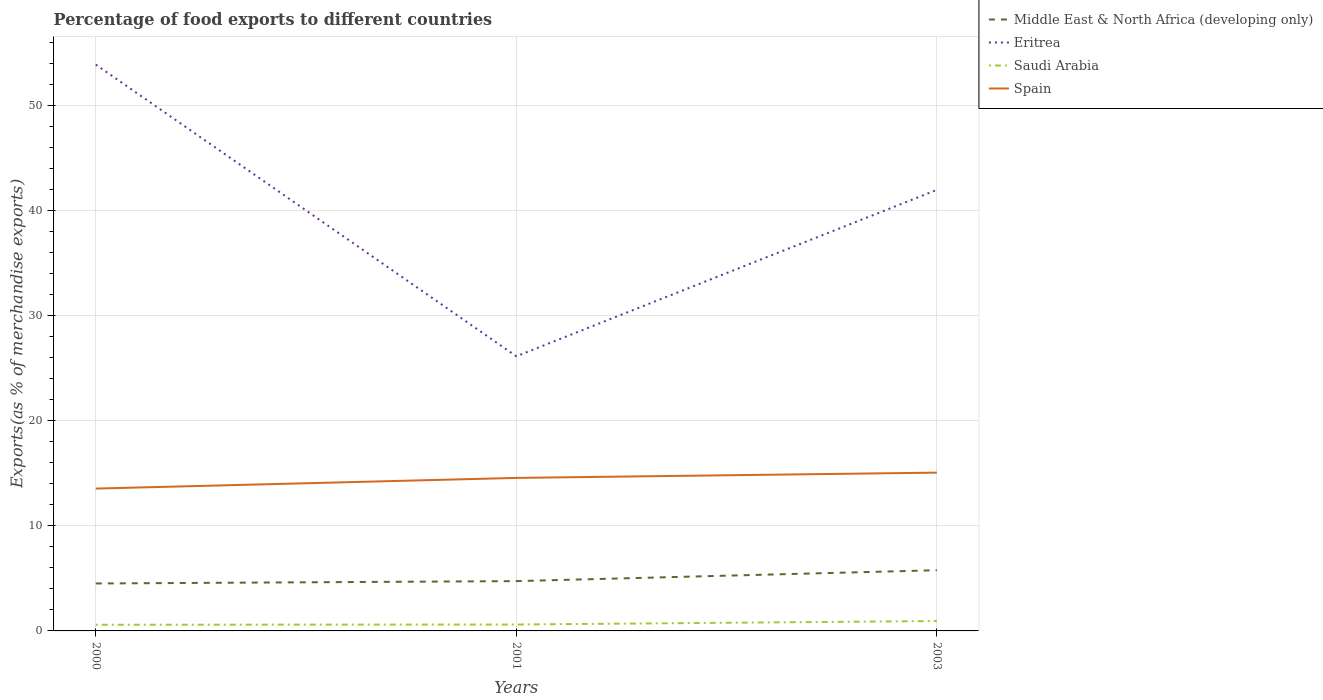How many different coloured lines are there?
Offer a very short reply. 4. Does the line corresponding to Spain intersect with the line corresponding to Middle East & North Africa (developing only)?
Offer a very short reply. No. Is the number of lines equal to the number of legend labels?
Your answer should be very brief. Yes. Across all years, what is the maximum percentage of exports to different countries in Eritrea?
Your response must be concise. 26.15. In which year was the percentage of exports to different countries in Middle East & North Africa (developing only) maximum?
Provide a succinct answer. 2000. What is the total percentage of exports to different countries in Spain in the graph?
Provide a short and direct response. -1.52. What is the difference between the highest and the second highest percentage of exports to different countries in Middle East & North Africa (developing only)?
Offer a very short reply. 1.26. What is the difference between the highest and the lowest percentage of exports to different countries in Saudi Arabia?
Your response must be concise. 1. Is the percentage of exports to different countries in Saudi Arabia strictly greater than the percentage of exports to different countries in Eritrea over the years?
Offer a very short reply. Yes. How many years are there in the graph?
Provide a succinct answer. 3. Does the graph contain grids?
Keep it short and to the point. Yes. How are the legend labels stacked?
Offer a very short reply. Vertical. What is the title of the graph?
Give a very brief answer. Percentage of food exports to different countries. Does "Lower middle income" appear as one of the legend labels in the graph?
Provide a succinct answer. No. What is the label or title of the X-axis?
Make the answer very short. Years. What is the label or title of the Y-axis?
Your answer should be very brief. Exports(as % of merchandise exports). What is the Exports(as % of merchandise exports) in Middle East & North Africa (developing only) in 2000?
Your answer should be compact. 4.52. What is the Exports(as % of merchandise exports) in Eritrea in 2000?
Offer a very short reply. 53.91. What is the Exports(as % of merchandise exports) in Saudi Arabia in 2000?
Your response must be concise. 0.59. What is the Exports(as % of merchandise exports) in Spain in 2000?
Provide a succinct answer. 13.55. What is the Exports(as % of merchandise exports) in Middle East & North Africa (developing only) in 2001?
Keep it short and to the point. 4.74. What is the Exports(as % of merchandise exports) in Eritrea in 2001?
Provide a short and direct response. 26.15. What is the Exports(as % of merchandise exports) in Saudi Arabia in 2001?
Offer a very short reply. 0.61. What is the Exports(as % of merchandise exports) of Spain in 2001?
Ensure brevity in your answer.  14.57. What is the Exports(as % of merchandise exports) in Middle East & North Africa (developing only) in 2003?
Your response must be concise. 5.78. What is the Exports(as % of merchandise exports) in Eritrea in 2003?
Keep it short and to the point. 41.99. What is the Exports(as % of merchandise exports) of Saudi Arabia in 2003?
Offer a very short reply. 0.94. What is the Exports(as % of merchandise exports) in Spain in 2003?
Give a very brief answer. 15.07. Across all years, what is the maximum Exports(as % of merchandise exports) of Middle East & North Africa (developing only)?
Your response must be concise. 5.78. Across all years, what is the maximum Exports(as % of merchandise exports) of Eritrea?
Offer a terse response. 53.91. Across all years, what is the maximum Exports(as % of merchandise exports) of Saudi Arabia?
Your answer should be compact. 0.94. Across all years, what is the maximum Exports(as % of merchandise exports) in Spain?
Your answer should be compact. 15.07. Across all years, what is the minimum Exports(as % of merchandise exports) of Middle East & North Africa (developing only)?
Give a very brief answer. 4.52. Across all years, what is the minimum Exports(as % of merchandise exports) of Eritrea?
Your response must be concise. 26.15. Across all years, what is the minimum Exports(as % of merchandise exports) in Saudi Arabia?
Make the answer very short. 0.59. Across all years, what is the minimum Exports(as % of merchandise exports) of Spain?
Give a very brief answer. 13.55. What is the total Exports(as % of merchandise exports) of Middle East & North Africa (developing only) in the graph?
Make the answer very short. 15.04. What is the total Exports(as % of merchandise exports) of Eritrea in the graph?
Provide a short and direct response. 122.05. What is the total Exports(as % of merchandise exports) in Saudi Arabia in the graph?
Your response must be concise. 2.14. What is the total Exports(as % of merchandise exports) of Spain in the graph?
Make the answer very short. 43.19. What is the difference between the Exports(as % of merchandise exports) of Middle East & North Africa (developing only) in 2000 and that in 2001?
Your answer should be compact. -0.22. What is the difference between the Exports(as % of merchandise exports) in Eritrea in 2000 and that in 2001?
Make the answer very short. 27.77. What is the difference between the Exports(as % of merchandise exports) of Saudi Arabia in 2000 and that in 2001?
Ensure brevity in your answer.  -0.02. What is the difference between the Exports(as % of merchandise exports) in Spain in 2000 and that in 2001?
Your response must be concise. -1.02. What is the difference between the Exports(as % of merchandise exports) in Middle East & North Africa (developing only) in 2000 and that in 2003?
Offer a terse response. -1.26. What is the difference between the Exports(as % of merchandise exports) of Eritrea in 2000 and that in 2003?
Ensure brevity in your answer.  11.93. What is the difference between the Exports(as % of merchandise exports) in Saudi Arabia in 2000 and that in 2003?
Your answer should be compact. -0.36. What is the difference between the Exports(as % of merchandise exports) in Spain in 2000 and that in 2003?
Provide a short and direct response. -1.52. What is the difference between the Exports(as % of merchandise exports) of Middle East & North Africa (developing only) in 2001 and that in 2003?
Your response must be concise. -1.04. What is the difference between the Exports(as % of merchandise exports) in Eritrea in 2001 and that in 2003?
Offer a very short reply. -15.84. What is the difference between the Exports(as % of merchandise exports) in Saudi Arabia in 2001 and that in 2003?
Your answer should be very brief. -0.33. What is the difference between the Exports(as % of merchandise exports) of Spain in 2001 and that in 2003?
Ensure brevity in your answer.  -0.5. What is the difference between the Exports(as % of merchandise exports) in Middle East & North Africa (developing only) in 2000 and the Exports(as % of merchandise exports) in Eritrea in 2001?
Make the answer very short. -21.63. What is the difference between the Exports(as % of merchandise exports) in Middle East & North Africa (developing only) in 2000 and the Exports(as % of merchandise exports) in Saudi Arabia in 2001?
Give a very brief answer. 3.91. What is the difference between the Exports(as % of merchandise exports) in Middle East & North Africa (developing only) in 2000 and the Exports(as % of merchandise exports) in Spain in 2001?
Provide a succinct answer. -10.05. What is the difference between the Exports(as % of merchandise exports) of Eritrea in 2000 and the Exports(as % of merchandise exports) of Saudi Arabia in 2001?
Keep it short and to the point. 53.31. What is the difference between the Exports(as % of merchandise exports) of Eritrea in 2000 and the Exports(as % of merchandise exports) of Spain in 2001?
Your response must be concise. 39.35. What is the difference between the Exports(as % of merchandise exports) of Saudi Arabia in 2000 and the Exports(as % of merchandise exports) of Spain in 2001?
Your response must be concise. -13.98. What is the difference between the Exports(as % of merchandise exports) in Middle East & North Africa (developing only) in 2000 and the Exports(as % of merchandise exports) in Eritrea in 2003?
Provide a short and direct response. -37.47. What is the difference between the Exports(as % of merchandise exports) in Middle East & North Africa (developing only) in 2000 and the Exports(as % of merchandise exports) in Saudi Arabia in 2003?
Provide a succinct answer. 3.57. What is the difference between the Exports(as % of merchandise exports) of Middle East & North Africa (developing only) in 2000 and the Exports(as % of merchandise exports) of Spain in 2003?
Your answer should be very brief. -10.55. What is the difference between the Exports(as % of merchandise exports) of Eritrea in 2000 and the Exports(as % of merchandise exports) of Saudi Arabia in 2003?
Provide a short and direct response. 52.97. What is the difference between the Exports(as % of merchandise exports) of Eritrea in 2000 and the Exports(as % of merchandise exports) of Spain in 2003?
Your response must be concise. 38.85. What is the difference between the Exports(as % of merchandise exports) in Saudi Arabia in 2000 and the Exports(as % of merchandise exports) in Spain in 2003?
Your answer should be compact. -14.48. What is the difference between the Exports(as % of merchandise exports) of Middle East & North Africa (developing only) in 2001 and the Exports(as % of merchandise exports) of Eritrea in 2003?
Offer a terse response. -37.25. What is the difference between the Exports(as % of merchandise exports) in Middle East & North Africa (developing only) in 2001 and the Exports(as % of merchandise exports) in Saudi Arabia in 2003?
Make the answer very short. 3.8. What is the difference between the Exports(as % of merchandise exports) of Middle East & North Africa (developing only) in 2001 and the Exports(as % of merchandise exports) of Spain in 2003?
Provide a short and direct response. -10.33. What is the difference between the Exports(as % of merchandise exports) of Eritrea in 2001 and the Exports(as % of merchandise exports) of Saudi Arabia in 2003?
Make the answer very short. 25.2. What is the difference between the Exports(as % of merchandise exports) of Eritrea in 2001 and the Exports(as % of merchandise exports) of Spain in 2003?
Provide a short and direct response. 11.08. What is the difference between the Exports(as % of merchandise exports) of Saudi Arabia in 2001 and the Exports(as % of merchandise exports) of Spain in 2003?
Your answer should be compact. -14.46. What is the average Exports(as % of merchandise exports) of Middle East & North Africa (developing only) per year?
Your answer should be very brief. 5.01. What is the average Exports(as % of merchandise exports) in Eritrea per year?
Make the answer very short. 40.68. What is the average Exports(as % of merchandise exports) in Saudi Arabia per year?
Offer a very short reply. 0.71. What is the average Exports(as % of merchandise exports) in Spain per year?
Your answer should be compact. 14.39. In the year 2000, what is the difference between the Exports(as % of merchandise exports) of Middle East & North Africa (developing only) and Exports(as % of merchandise exports) of Eritrea?
Ensure brevity in your answer.  -49.4. In the year 2000, what is the difference between the Exports(as % of merchandise exports) in Middle East & North Africa (developing only) and Exports(as % of merchandise exports) in Saudi Arabia?
Give a very brief answer. 3.93. In the year 2000, what is the difference between the Exports(as % of merchandise exports) in Middle East & North Africa (developing only) and Exports(as % of merchandise exports) in Spain?
Your answer should be compact. -9.03. In the year 2000, what is the difference between the Exports(as % of merchandise exports) in Eritrea and Exports(as % of merchandise exports) in Saudi Arabia?
Provide a succinct answer. 53.33. In the year 2000, what is the difference between the Exports(as % of merchandise exports) in Eritrea and Exports(as % of merchandise exports) in Spain?
Your response must be concise. 40.37. In the year 2000, what is the difference between the Exports(as % of merchandise exports) in Saudi Arabia and Exports(as % of merchandise exports) in Spain?
Your answer should be compact. -12.96. In the year 2001, what is the difference between the Exports(as % of merchandise exports) in Middle East & North Africa (developing only) and Exports(as % of merchandise exports) in Eritrea?
Provide a succinct answer. -21.4. In the year 2001, what is the difference between the Exports(as % of merchandise exports) in Middle East & North Africa (developing only) and Exports(as % of merchandise exports) in Saudi Arabia?
Make the answer very short. 4.13. In the year 2001, what is the difference between the Exports(as % of merchandise exports) in Middle East & North Africa (developing only) and Exports(as % of merchandise exports) in Spain?
Offer a terse response. -9.83. In the year 2001, what is the difference between the Exports(as % of merchandise exports) of Eritrea and Exports(as % of merchandise exports) of Saudi Arabia?
Ensure brevity in your answer.  25.54. In the year 2001, what is the difference between the Exports(as % of merchandise exports) in Eritrea and Exports(as % of merchandise exports) in Spain?
Your answer should be very brief. 11.58. In the year 2001, what is the difference between the Exports(as % of merchandise exports) in Saudi Arabia and Exports(as % of merchandise exports) in Spain?
Make the answer very short. -13.96. In the year 2003, what is the difference between the Exports(as % of merchandise exports) of Middle East & North Africa (developing only) and Exports(as % of merchandise exports) of Eritrea?
Provide a short and direct response. -36.21. In the year 2003, what is the difference between the Exports(as % of merchandise exports) of Middle East & North Africa (developing only) and Exports(as % of merchandise exports) of Saudi Arabia?
Your answer should be compact. 4.84. In the year 2003, what is the difference between the Exports(as % of merchandise exports) in Middle East & North Africa (developing only) and Exports(as % of merchandise exports) in Spain?
Your answer should be very brief. -9.29. In the year 2003, what is the difference between the Exports(as % of merchandise exports) of Eritrea and Exports(as % of merchandise exports) of Saudi Arabia?
Ensure brevity in your answer.  41.04. In the year 2003, what is the difference between the Exports(as % of merchandise exports) of Eritrea and Exports(as % of merchandise exports) of Spain?
Make the answer very short. 26.92. In the year 2003, what is the difference between the Exports(as % of merchandise exports) of Saudi Arabia and Exports(as % of merchandise exports) of Spain?
Your answer should be very brief. -14.13. What is the ratio of the Exports(as % of merchandise exports) in Middle East & North Africa (developing only) in 2000 to that in 2001?
Offer a terse response. 0.95. What is the ratio of the Exports(as % of merchandise exports) of Eritrea in 2000 to that in 2001?
Offer a very short reply. 2.06. What is the ratio of the Exports(as % of merchandise exports) of Saudi Arabia in 2000 to that in 2001?
Provide a short and direct response. 0.96. What is the ratio of the Exports(as % of merchandise exports) in Spain in 2000 to that in 2001?
Keep it short and to the point. 0.93. What is the ratio of the Exports(as % of merchandise exports) in Middle East & North Africa (developing only) in 2000 to that in 2003?
Offer a very short reply. 0.78. What is the ratio of the Exports(as % of merchandise exports) in Eritrea in 2000 to that in 2003?
Give a very brief answer. 1.28. What is the ratio of the Exports(as % of merchandise exports) in Saudi Arabia in 2000 to that in 2003?
Make the answer very short. 0.62. What is the ratio of the Exports(as % of merchandise exports) of Spain in 2000 to that in 2003?
Keep it short and to the point. 0.9. What is the ratio of the Exports(as % of merchandise exports) of Middle East & North Africa (developing only) in 2001 to that in 2003?
Your answer should be very brief. 0.82. What is the ratio of the Exports(as % of merchandise exports) in Eritrea in 2001 to that in 2003?
Ensure brevity in your answer.  0.62. What is the ratio of the Exports(as % of merchandise exports) in Saudi Arabia in 2001 to that in 2003?
Your answer should be very brief. 0.65. What is the ratio of the Exports(as % of merchandise exports) in Spain in 2001 to that in 2003?
Your answer should be compact. 0.97. What is the difference between the highest and the second highest Exports(as % of merchandise exports) in Middle East & North Africa (developing only)?
Offer a terse response. 1.04. What is the difference between the highest and the second highest Exports(as % of merchandise exports) in Eritrea?
Keep it short and to the point. 11.93. What is the difference between the highest and the second highest Exports(as % of merchandise exports) in Saudi Arabia?
Your answer should be compact. 0.33. What is the difference between the highest and the second highest Exports(as % of merchandise exports) in Spain?
Your answer should be very brief. 0.5. What is the difference between the highest and the lowest Exports(as % of merchandise exports) of Middle East & North Africa (developing only)?
Provide a succinct answer. 1.26. What is the difference between the highest and the lowest Exports(as % of merchandise exports) in Eritrea?
Keep it short and to the point. 27.77. What is the difference between the highest and the lowest Exports(as % of merchandise exports) of Saudi Arabia?
Your answer should be compact. 0.36. What is the difference between the highest and the lowest Exports(as % of merchandise exports) in Spain?
Provide a succinct answer. 1.52. 